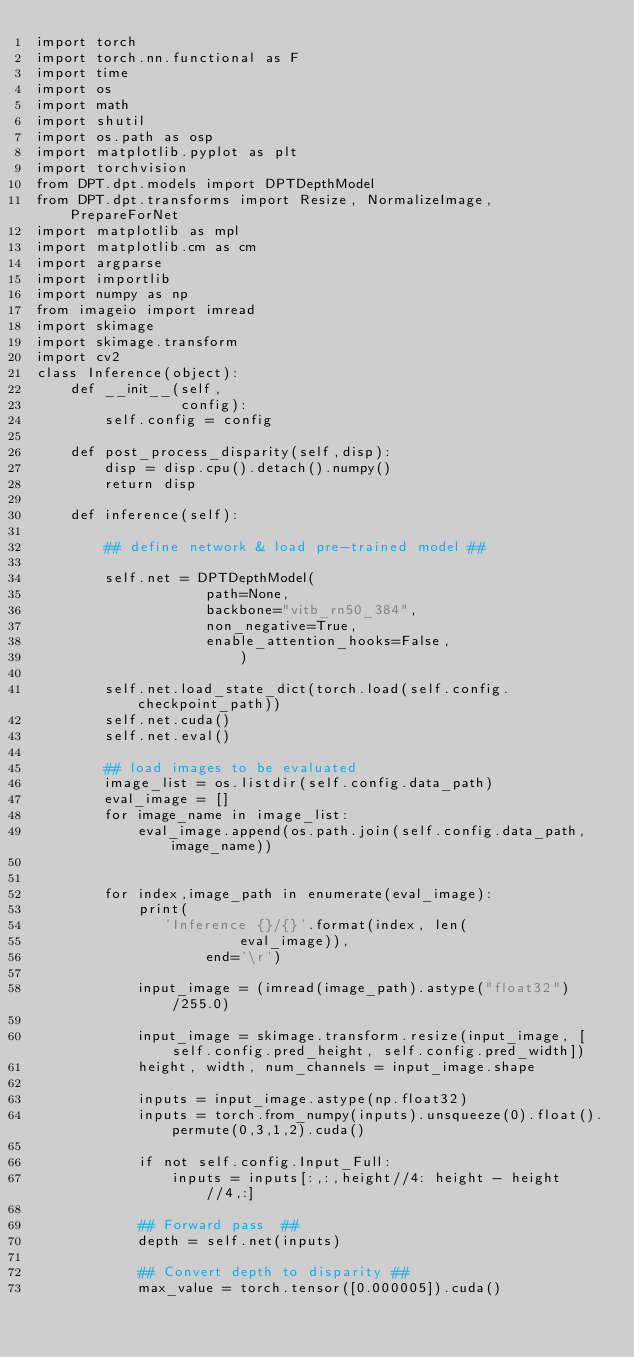Convert code to text. <code><loc_0><loc_0><loc_500><loc_500><_Python_>import torch
import torch.nn.functional as F
import time
import os
import math
import shutil
import os.path as osp
import matplotlib.pyplot as plt
import torchvision
from DPT.dpt.models import DPTDepthModel
from DPT.dpt.transforms import Resize, NormalizeImage, PrepareForNet
import matplotlib as mpl
import matplotlib.cm as cm
import argparse
import importlib
import numpy as np
from imageio import imread
import skimage
import skimage.transform
import cv2
class Inference(object):
    def __init__(self,
                 config):
        self.config = config
        
    def post_process_disparity(self,disp):
        disp = disp.cpu().detach().numpy()
        return disp   
    
    def inference(self):

        ## define network & load pre-trained model ##

        self.net = DPTDepthModel(
                    path=None,
                    backbone="vitb_rn50_384",
                    non_negative=True,
                    enable_attention_hooks=False,
                        )

        self.net.load_state_dict(torch.load(self.config.checkpoint_path))
        self.net.cuda()
        self.net.eval()

        ## load images to be evaluated
        image_list = os.listdir(self.config.data_path)
        eval_image = []
        for image_name in image_list:
            eval_image.append(os.path.join(self.config.data_path,image_name))
       
        
        for index,image_path in enumerate(eval_image):
            print(
               'Inference {}/{}'.format(index, len(
                        eval_image)),
                    end='\r')
             
            input_image = (imread(image_path).astype("float32")/255.0)
            
            input_image = skimage.transform.resize(input_image, [self.config.pred_height, self.config.pred_width])
            height, width, num_channels = input_image.shape
            
            inputs = input_image.astype(np.float32)
            inputs = torch.from_numpy(inputs).unsqueeze(0).float().permute(0,3,1,2).cuda()
            
            if not self.config.Input_Full:
                inputs = inputs[:,:,height//4: height - height//4,:]

            ## Forward pass  ##
            depth = self.net(inputs)

            ## Convert depth to disparity ## 
            max_value = torch.tensor([0.000005]).cuda()</code> 